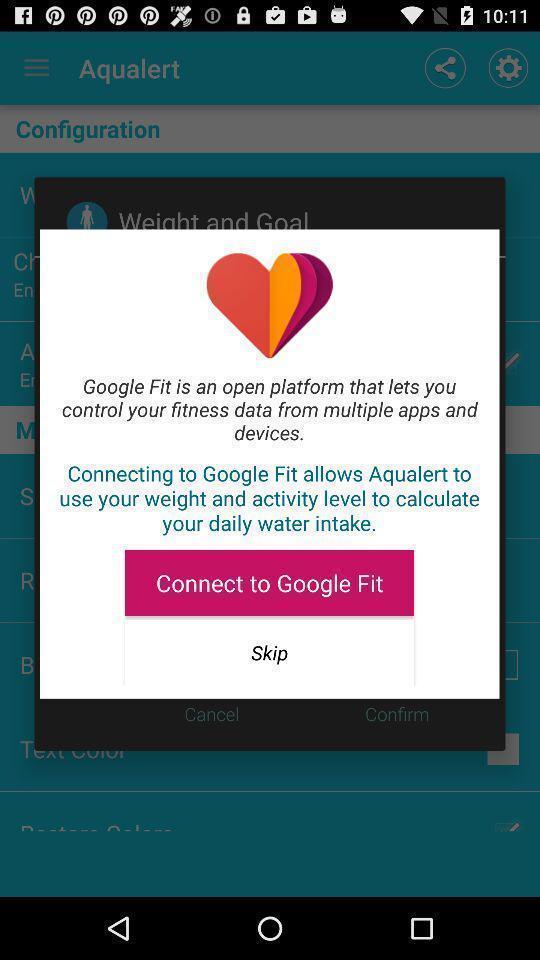Summarize the main components in this picture. Popup to connect to a device in a health app. 